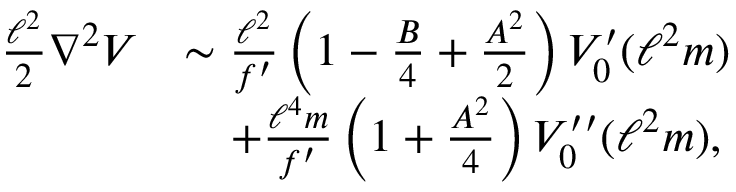<formula> <loc_0><loc_0><loc_500><loc_500>\begin{array} { r l } { \frac { \ell ^ { 2 } } { 2 } \nabla ^ { 2 } V } & { \sim \frac { \ell ^ { 2 } } { f ^ { \prime } } \left ( 1 - \frac { B } { 4 } + \frac { A ^ { 2 } } { 2 } \right ) V _ { 0 } ^ { \prime } ( \ell ^ { 2 } m ) } \\ & { \quad + \frac { \ell ^ { 4 } m } { f ^ { \prime } } \left ( 1 + \frac { A ^ { 2 } } { 4 } \right ) V _ { 0 } ^ { \prime \prime } ( \ell ^ { 2 } m ) , } \end{array}</formula> 